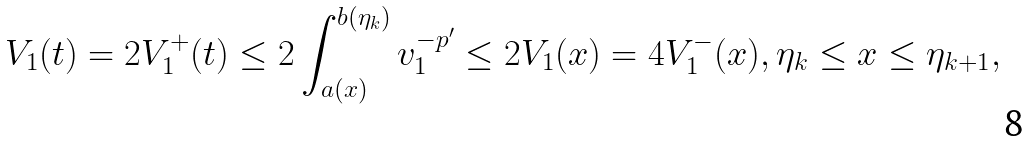<formula> <loc_0><loc_0><loc_500><loc_500>V _ { 1 } ( t ) = 2 V _ { 1 } ^ { + } ( t ) \leq 2 \int _ { a ( x ) } ^ { b ( \eta _ { k } ) } v _ { 1 } ^ { - p ^ { \prime } } \leq 2 V _ { 1 } ( x ) = 4 V _ { 1 } ^ { - } ( x ) , \eta _ { k } \leq x \leq \eta _ { k + 1 } ,</formula> 